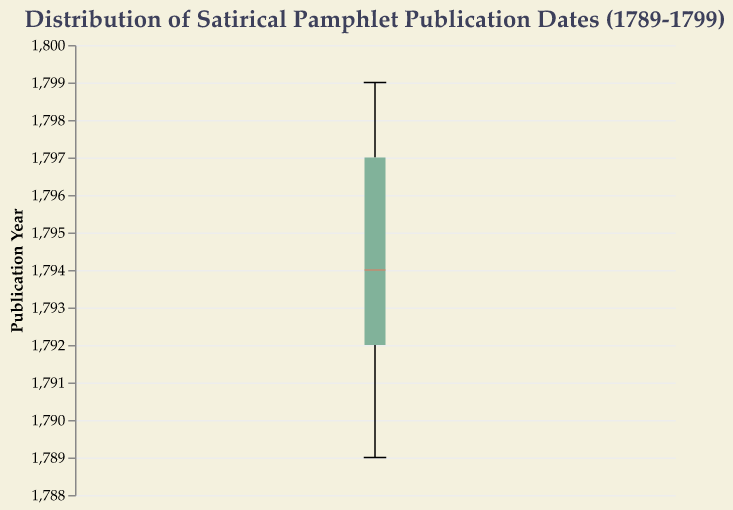What is the title of the plot? The title is usually placed at the top of the plot and describes the subject of the visualization. In this case, the title helps us understand what the plot is representing.
Answer: Distribution of Satirical Pamphlet Publication Dates (1789-1799) How many pamphlets were published in 1793 according to the plot? To find the number of publications in 1793, look at the plot's data points around the year 1793 and count them.
Answer: 3 What's the median publication year of the satirical pamphlets? The median is usually highlighted on a box plot. Locate the middle line inside the box, which represents the median year.
Answer: 1794 What is the range of publication years shown on the y-axis? The range is determined by looking at the lowest and highest values on the y-axis.
Answer: 1789 to 1799 Which year had the highest number of satirical pamphlet publications according to the box plot? Identify the year with the most "ticks" or data points piled up on that year.
Answer: 1793 What is the interquartile range (IQR) of publication years? The IQR is the range between the first quartile (Q1) and the third quartile (Q3) on the box plot. The bottom of the box represents Q1 and the top represents Q3.
Answer: 1792 to 1797 How does the median publication year compare to the overall range of publication years? The median divides the data into two halves and is located roughly at the midpoint of the overall range. This involves observing the position of the median line relative to the minimum and maximum values.
Answer: The median is closer to the middle of the range What is the shape of the distribution of publication years? Look at the spread and clustering of data points on the box plot to determine the distribution's shape. If the data points are spread evenly, the distribution is uniform; if clustered, it can be skewed.
Answer: The distribution shows clustering around certain years, especially 1793 and 1797 What does the notch in a notched box plot represent? The notch in a box plot gives a visual assessment of the statistical significance of the median differences. It represents the confidence interval around the median.
Answer: Confidence interval of the median 